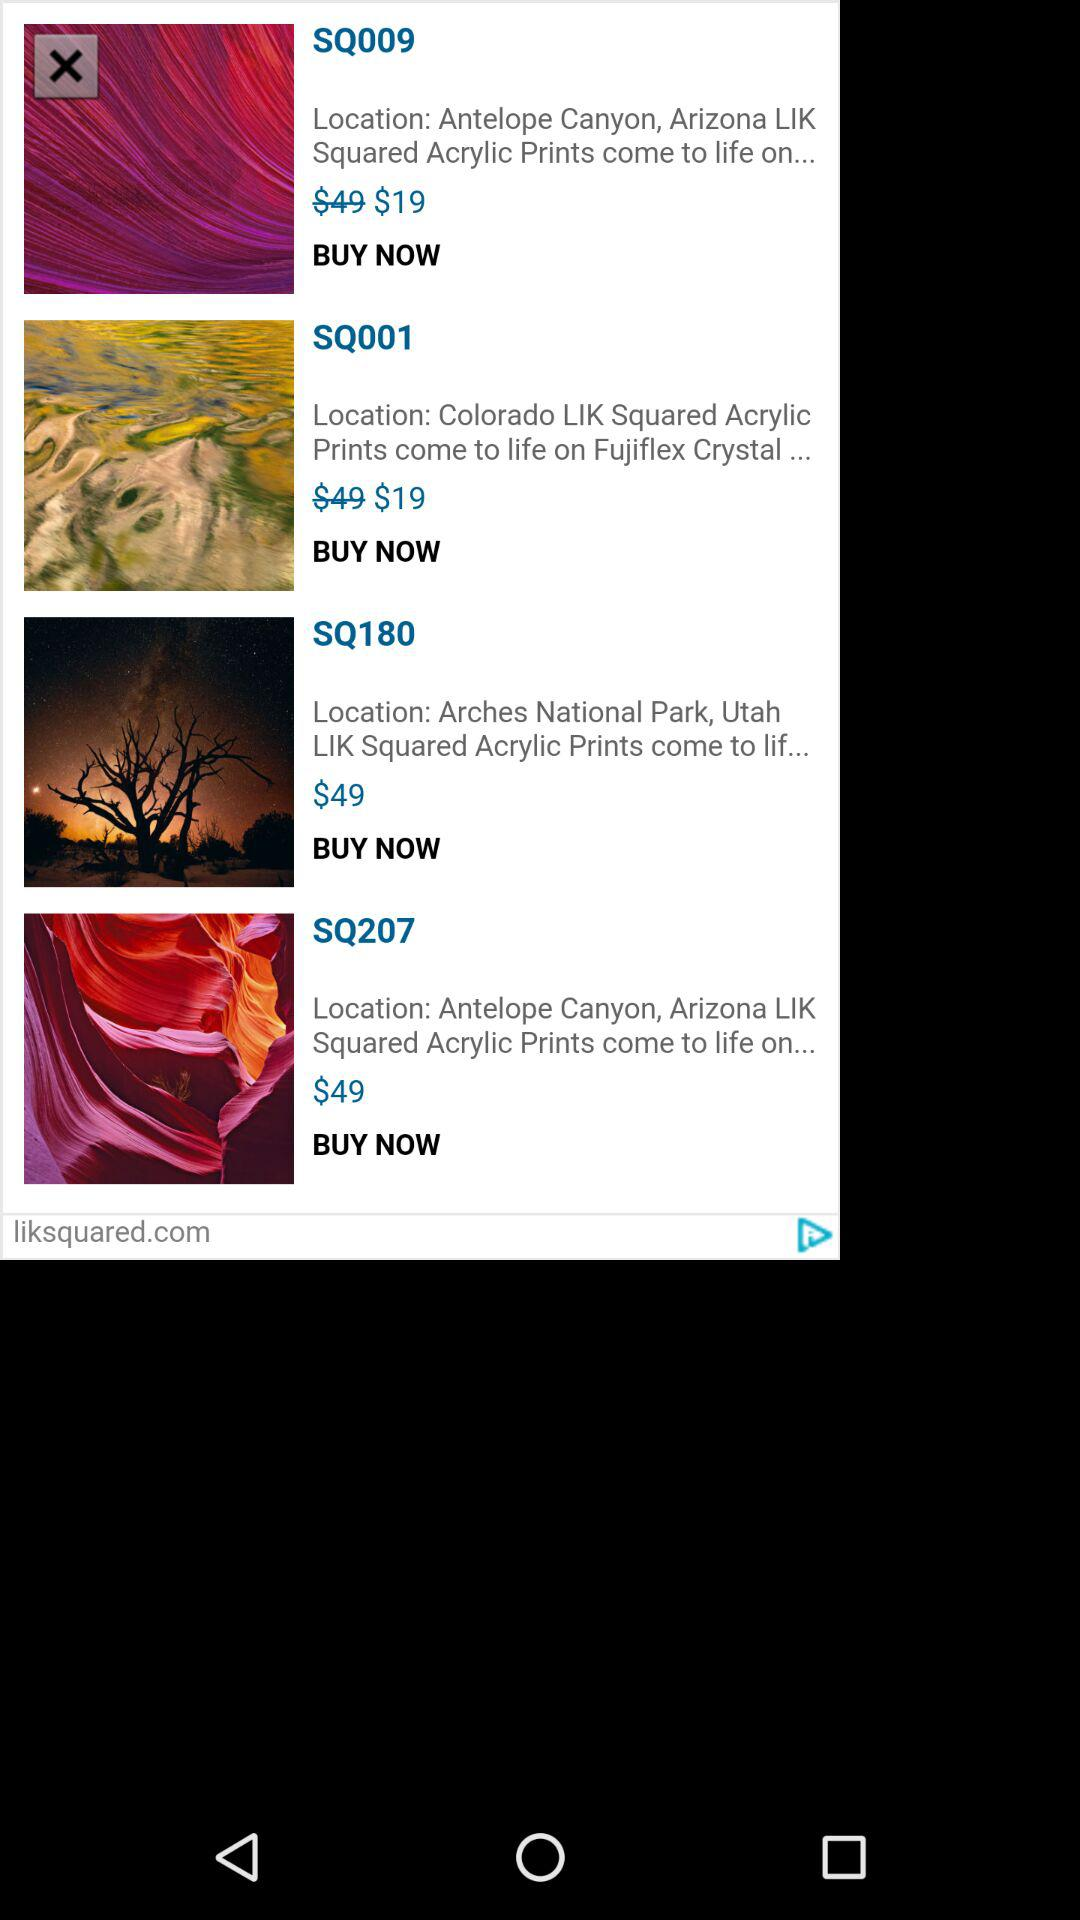What is the price of "SQ180"? The price is $49. 